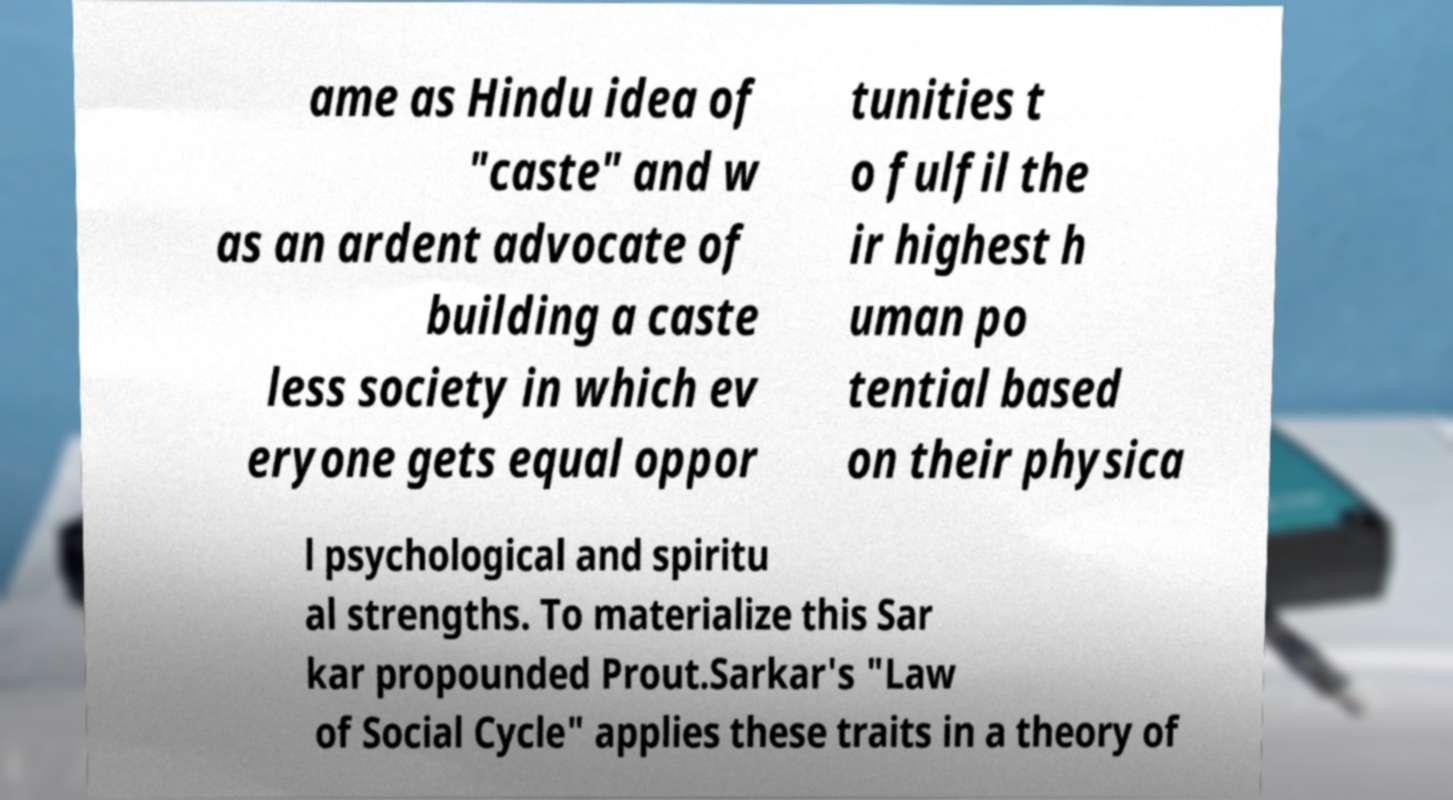What messages or text are displayed in this image? I need them in a readable, typed format. ame as Hindu idea of "caste" and w as an ardent advocate of building a caste less society in which ev eryone gets equal oppor tunities t o fulfil the ir highest h uman po tential based on their physica l psychological and spiritu al strengths. To materialize this Sar kar propounded Prout.Sarkar's "Law of Social Cycle" applies these traits in a theory of 